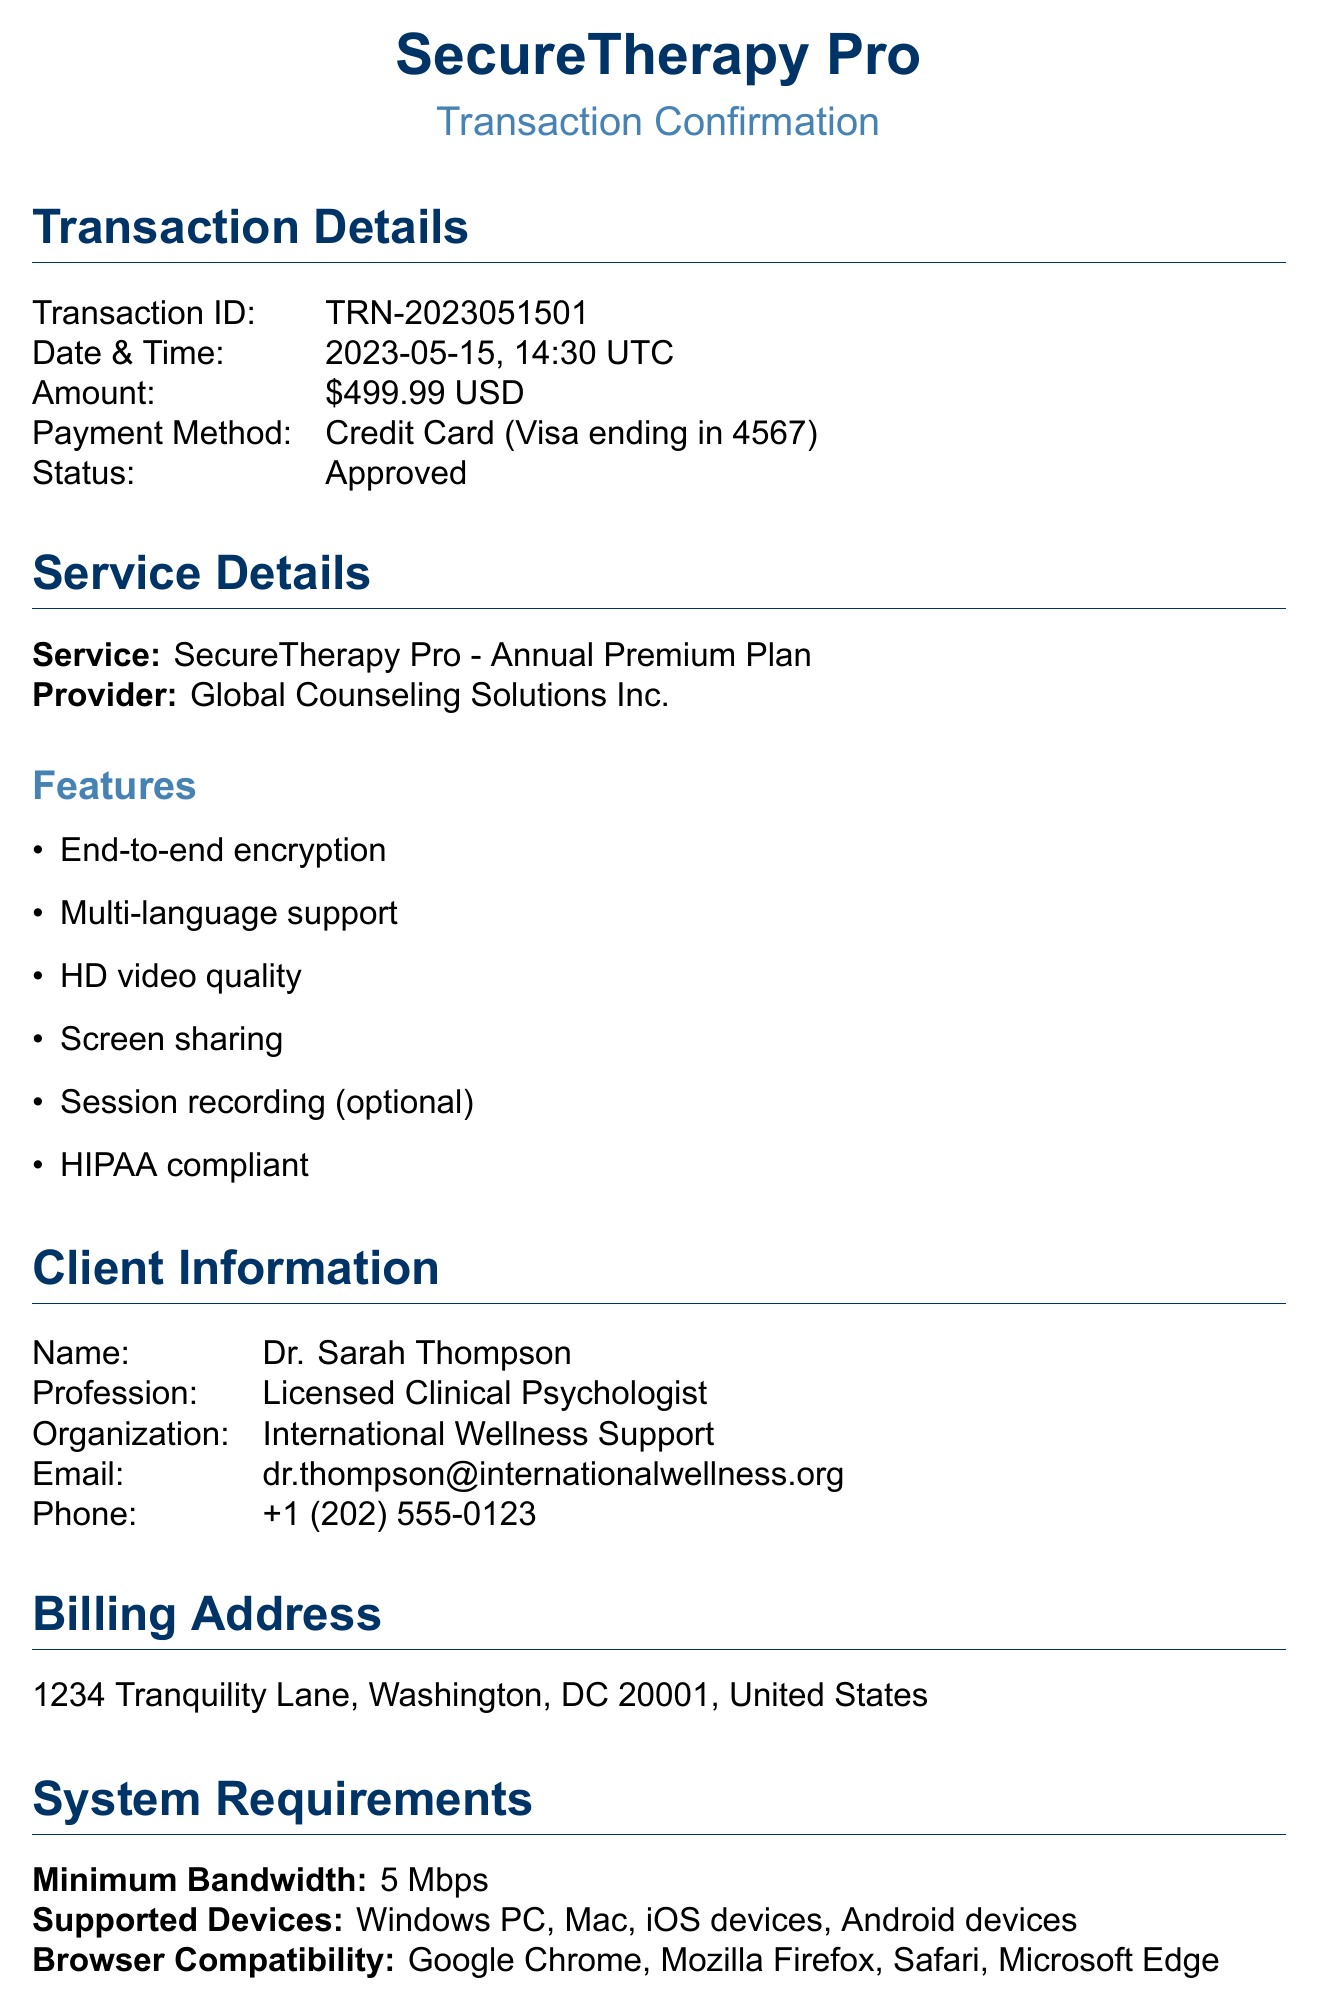What is the transaction ID? The transaction ID is a unique identifier for this payment, as listed in the document.
Answer: TRN-2023051501 What date was the payment processed? The date mentioned in the transaction details specifies when the payment was made.
Answer: 2023-05-15 What service is provided under this transaction? The document states the name of the service being paid for, which is related to the transaction.
Answer: SecureTherapy Pro Who is the client? The client's name is clearly stated in the client information section of the document.
Answer: Dr. Sarah Thompson What is the payment amount? The document specifies the amount that was charged for the service being provided.
Answer: $499.99 What are the supported devices for the service? This question asks for a list of devices that are compatible with the service as stated in the document.
Answer: Windows PC, Mac, iOS devices, Android devices What encryption standard is used for data security? This question focuses on the security measures outlined in the document, particularly regarding data encryption.
Answer: AES-256 Is there a support team available? The document includes information about support availability, indicating whether assistance can be obtained.
Answer: Yes What is included in the additional notes? The additional notes section provides extra information that helps understand the service better.
Answer: Customization, training, data retention, emergency protocol 